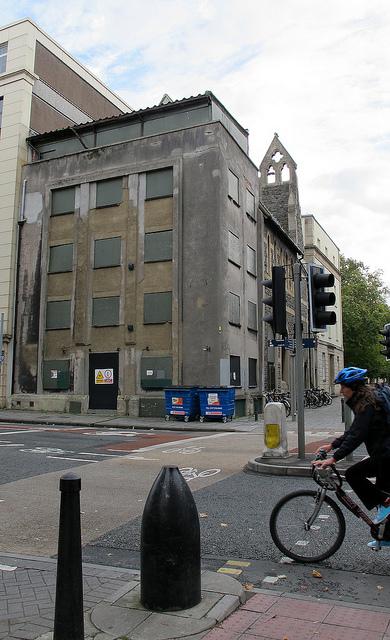What model bike is that?
Keep it brief. Schwinn. What vehicle is the woman riding?
Give a very brief answer. Bicycle. Is the bicycle rider wearing a helmet?
Be succinct. Yes. 